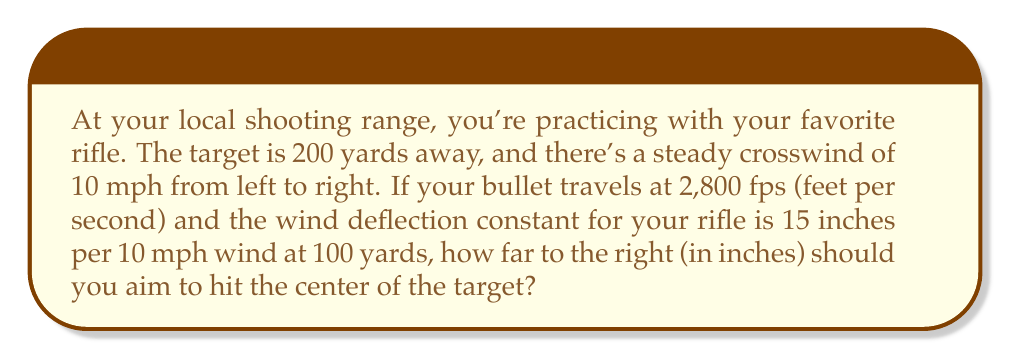What is the answer to this math problem? Let's break this down step-by-step:

1) First, we need to calculate the time of flight for the bullet. We can use the distance and velocity to do this:

   Time of flight = Distance / Velocity
   $$ t = \frac{200 \text{ yards} \times 3 \text{ feet/yard}}{2800 \text{ feet/second}} = 0.214 \text{ seconds} $$

2) Now, we know that the wind deflection constant is 15 inches per 10 mph wind at 100 yards. We need to adjust this for our 200-yard distance:

   At 200 yards, the deflection would be doubled: $15 \times 2 = 30$ inches

3) The wind speed is exactly 10 mph, which matches our constant, so we don't need to adjust for wind speed.

4) Now, we can calculate the wind drift:

   $$ \text{Wind Drift} = 30 \text{ inches} \times 0.214 \text{ seconds} = 6.42 \text{ inches} $$

5) This means the bullet will drift 6.42 inches to the right over its flight path.

6) Therefore, to hit the center of the target, you need to aim 6.42 inches to the left of the center.
Answer: $6.42$ inches to the left 